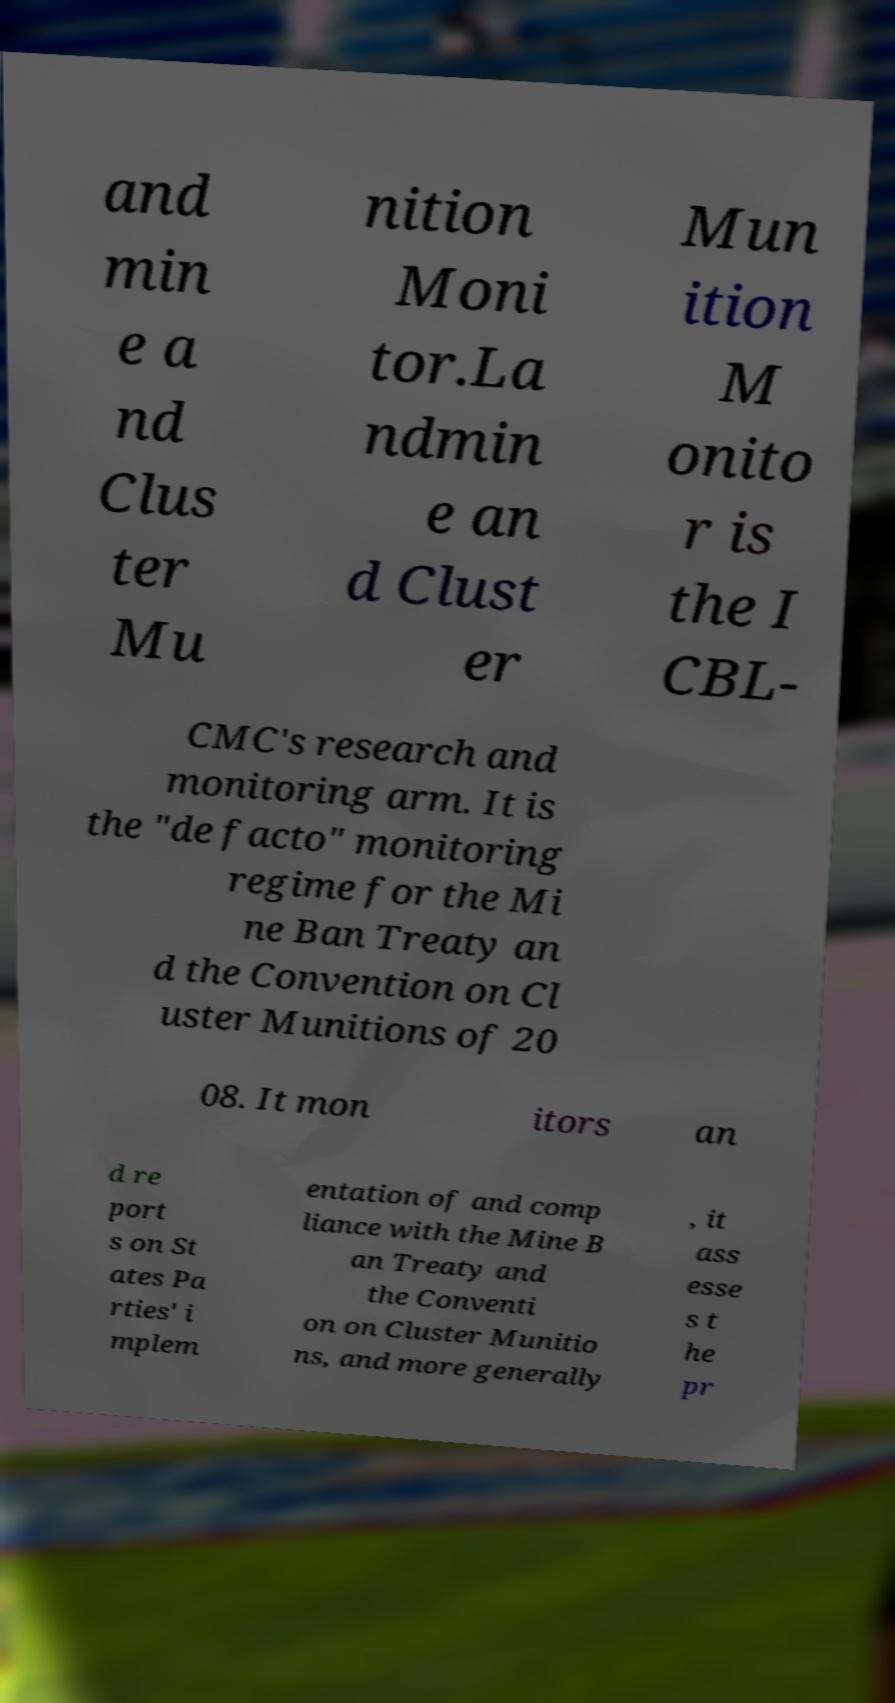Please identify and transcribe the text found in this image. and min e a nd Clus ter Mu nition Moni tor.La ndmin e an d Clust er Mun ition M onito r is the I CBL- CMC's research and monitoring arm. It is the "de facto" monitoring regime for the Mi ne Ban Treaty an d the Convention on Cl uster Munitions of 20 08. It mon itors an d re port s on St ates Pa rties' i mplem entation of and comp liance with the Mine B an Treaty and the Conventi on on Cluster Munitio ns, and more generally , it ass esse s t he pr 